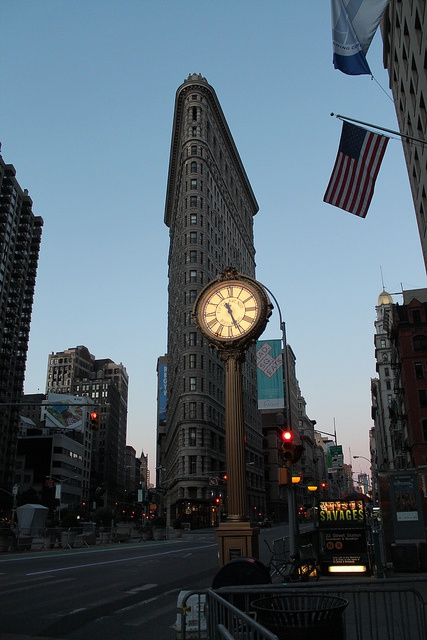Describe the objects in this image and their specific colors. I can see clock in gray, khaki, and tan tones, traffic light in gray, black, maroon, red, and brown tones, people in black and gray tones, traffic light in gray, black, maroon, red, and brown tones, and traffic light in gray, maroon, black, red, and brown tones in this image. 